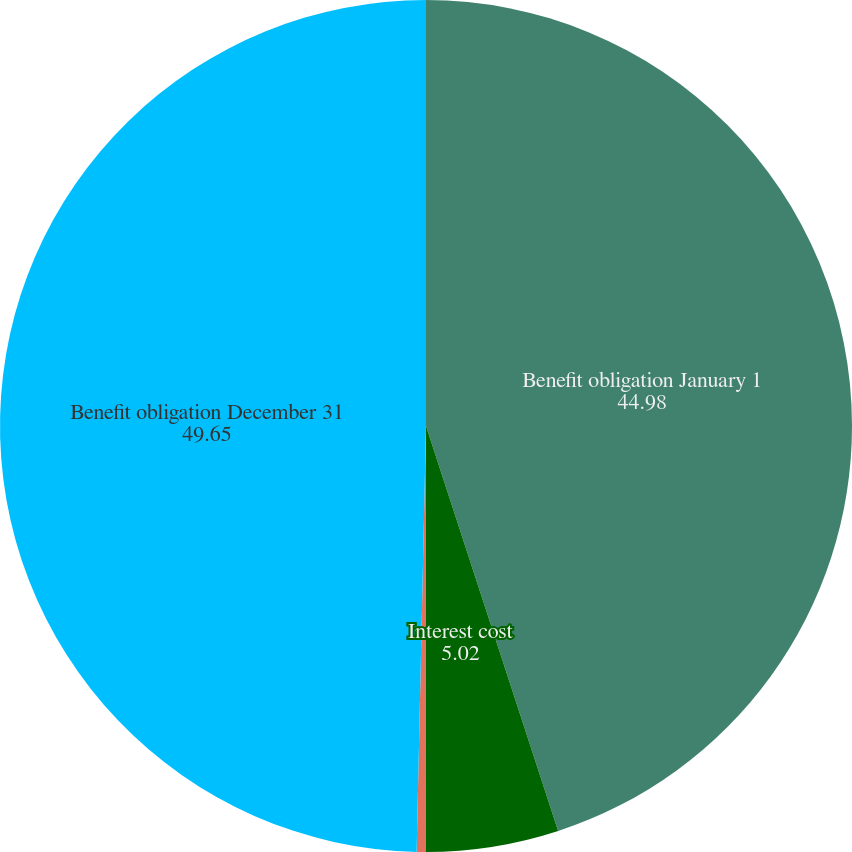Convert chart. <chart><loc_0><loc_0><loc_500><loc_500><pie_chart><fcel>Benefit obligation January 1<fcel>Interest cost<fcel>Benefits paid<fcel>Benefit obligation December 31<nl><fcel>44.98%<fcel>5.02%<fcel>0.35%<fcel>49.65%<nl></chart> 